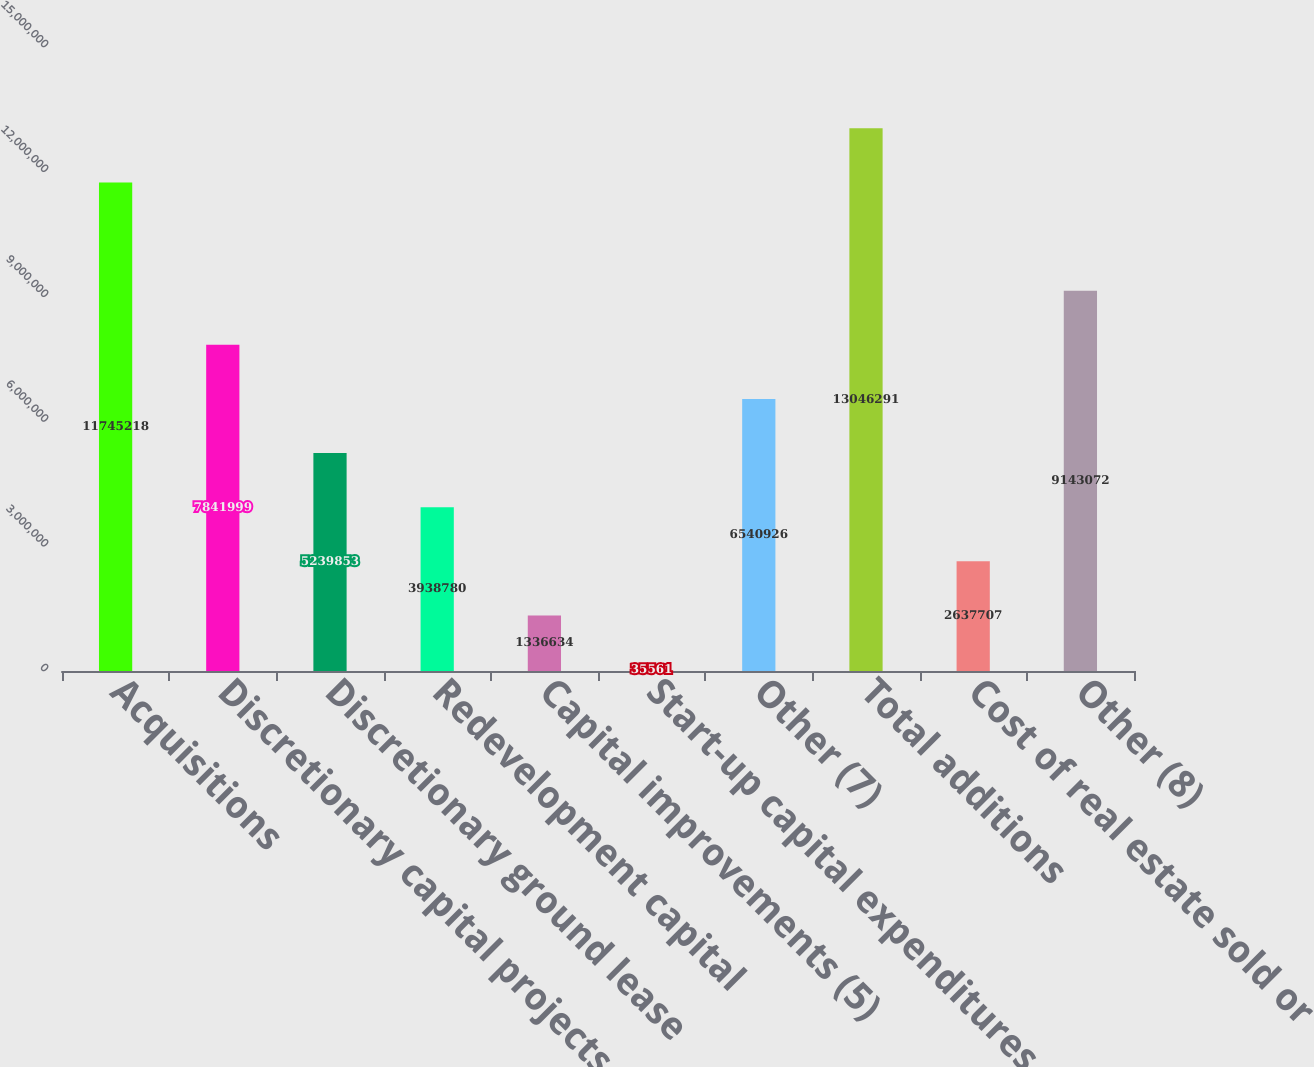Convert chart. <chart><loc_0><loc_0><loc_500><loc_500><bar_chart><fcel>Acquisitions<fcel>Discretionary capital projects<fcel>Discretionary ground lease<fcel>Redevelopment capital<fcel>Capital improvements (5)<fcel>Start-up capital expenditures<fcel>Other (7)<fcel>Total additions<fcel>Cost of real estate sold or<fcel>Other (8)<nl><fcel>1.17452e+07<fcel>7.842e+06<fcel>5.23985e+06<fcel>3.93878e+06<fcel>1.33663e+06<fcel>35561<fcel>6.54093e+06<fcel>1.30463e+07<fcel>2.63771e+06<fcel>9.14307e+06<nl></chart> 